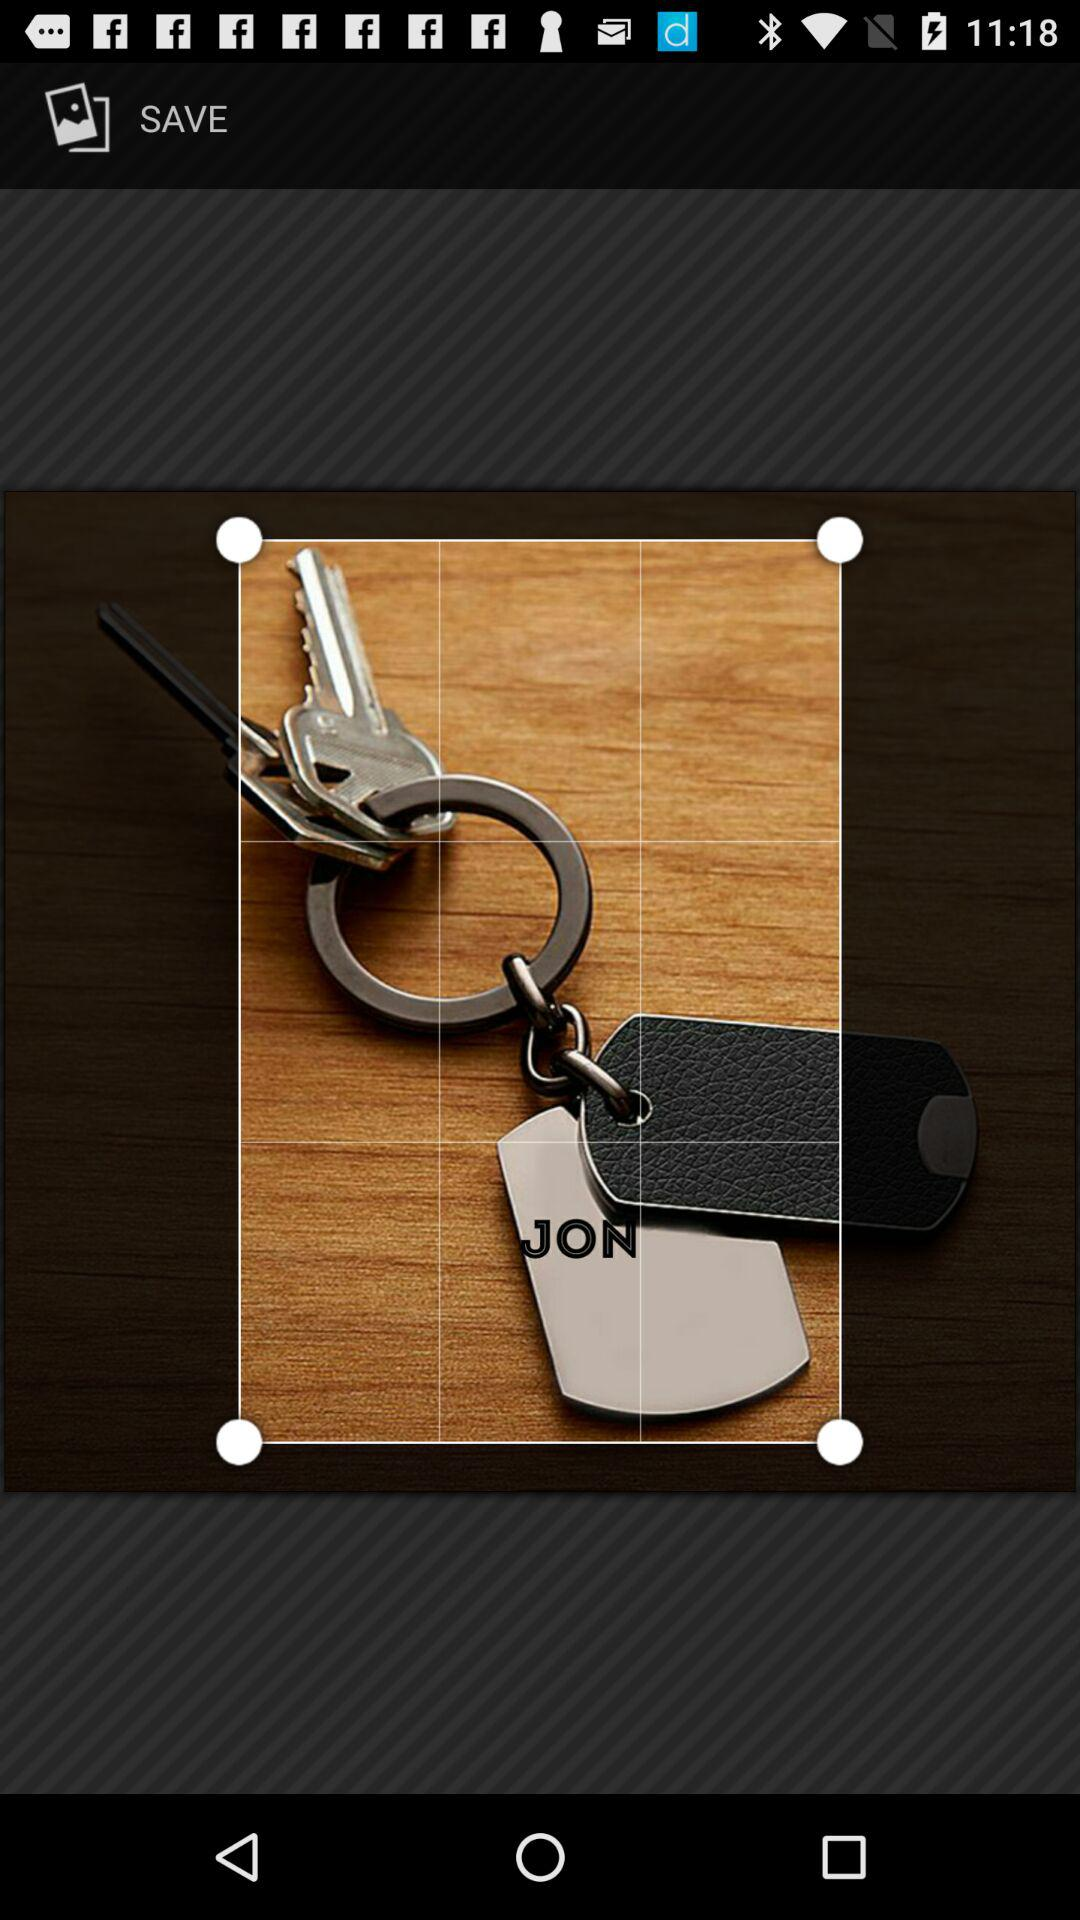What is the name of the person on the keychain?
Answer the question using a single word or phrase. JON 